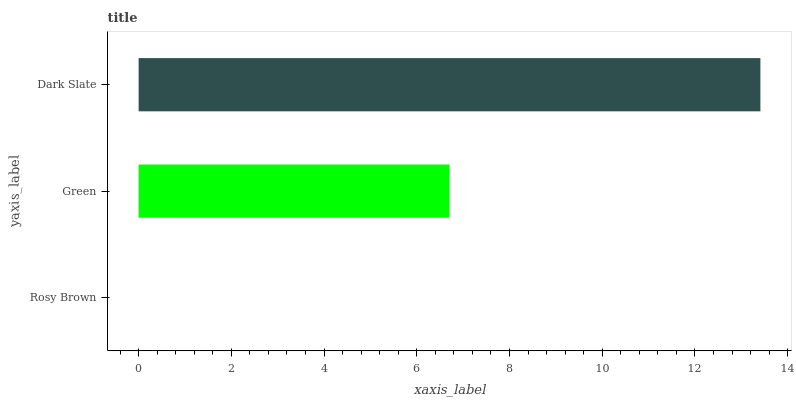Is Rosy Brown the minimum?
Answer yes or no. Yes. Is Dark Slate the maximum?
Answer yes or no. Yes. Is Green the minimum?
Answer yes or no. No. Is Green the maximum?
Answer yes or no. No. Is Green greater than Rosy Brown?
Answer yes or no. Yes. Is Rosy Brown less than Green?
Answer yes or no. Yes. Is Rosy Brown greater than Green?
Answer yes or no. No. Is Green less than Rosy Brown?
Answer yes or no. No. Is Green the high median?
Answer yes or no. Yes. Is Green the low median?
Answer yes or no. Yes. Is Dark Slate the high median?
Answer yes or no. No. Is Dark Slate the low median?
Answer yes or no. No. 